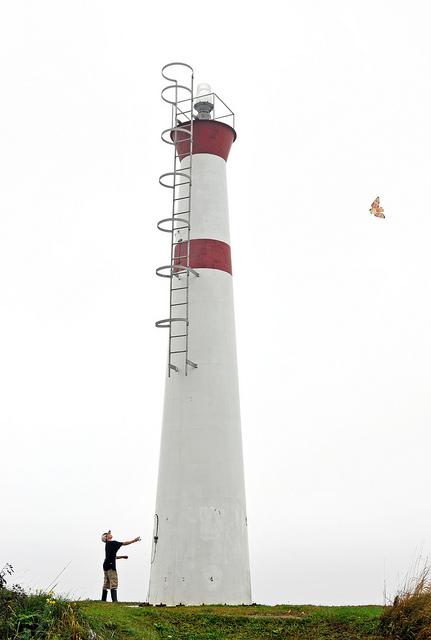What is the purpose of the structure?
Answer briefly. Light. What kind of building is this?
Concise answer only. Lighthouse. How many rungs are on the latter?
Keep it brief. 12. 